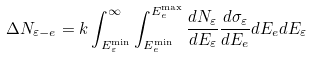Convert formula to latex. <formula><loc_0><loc_0><loc_500><loc_500>\Delta N _ { \varepsilon - e } = k \int ^ { \infty } _ { E _ { \varepsilon } ^ { \min } } \int ^ { E _ { e } ^ { \max } } _ { E _ { e } ^ { \min } } \frac { d N _ { \varepsilon } } { d E _ { \varepsilon } } \frac { d \sigma _ { \varepsilon } } { d E _ { e } } d E _ { e } d E _ { \varepsilon }</formula> 